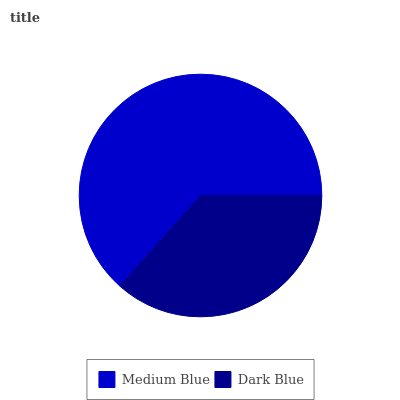Is Dark Blue the minimum?
Answer yes or no. Yes. Is Medium Blue the maximum?
Answer yes or no. Yes. Is Dark Blue the maximum?
Answer yes or no. No. Is Medium Blue greater than Dark Blue?
Answer yes or no. Yes. Is Dark Blue less than Medium Blue?
Answer yes or no. Yes. Is Dark Blue greater than Medium Blue?
Answer yes or no. No. Is Medium Blue less than Dark Blue?
Answer yes or no. No. Is Medium Blue the high median?
Answer yes or no. Yes. Is Dark Blue the low median?
Answer yes or no. Yes. Is Dark Blue the high median?
Answer yes or no. No. Is Medium Blue the low median?
Answer yes or no. No. 